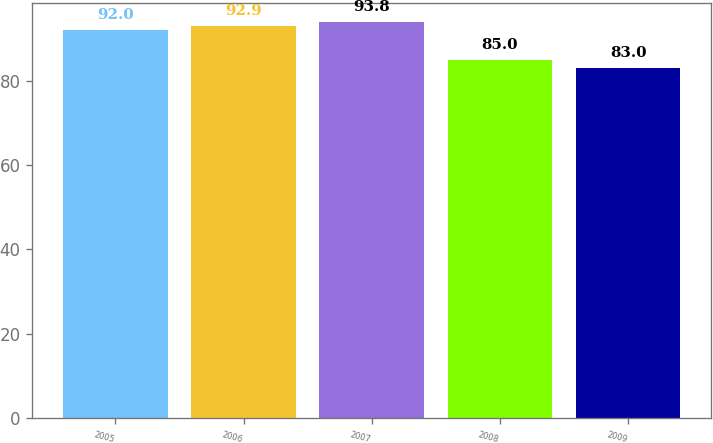<chart> <loc_0><loc_0><loc_500><loc_500><bar_chart><fcel>2005<fcel>2006<fcel>2007<fcel>2008<fcel>2009<nl><fcel>92<fcel>92.9<fcel>93.8<fcel>85<fcel>83<nl></chart> 